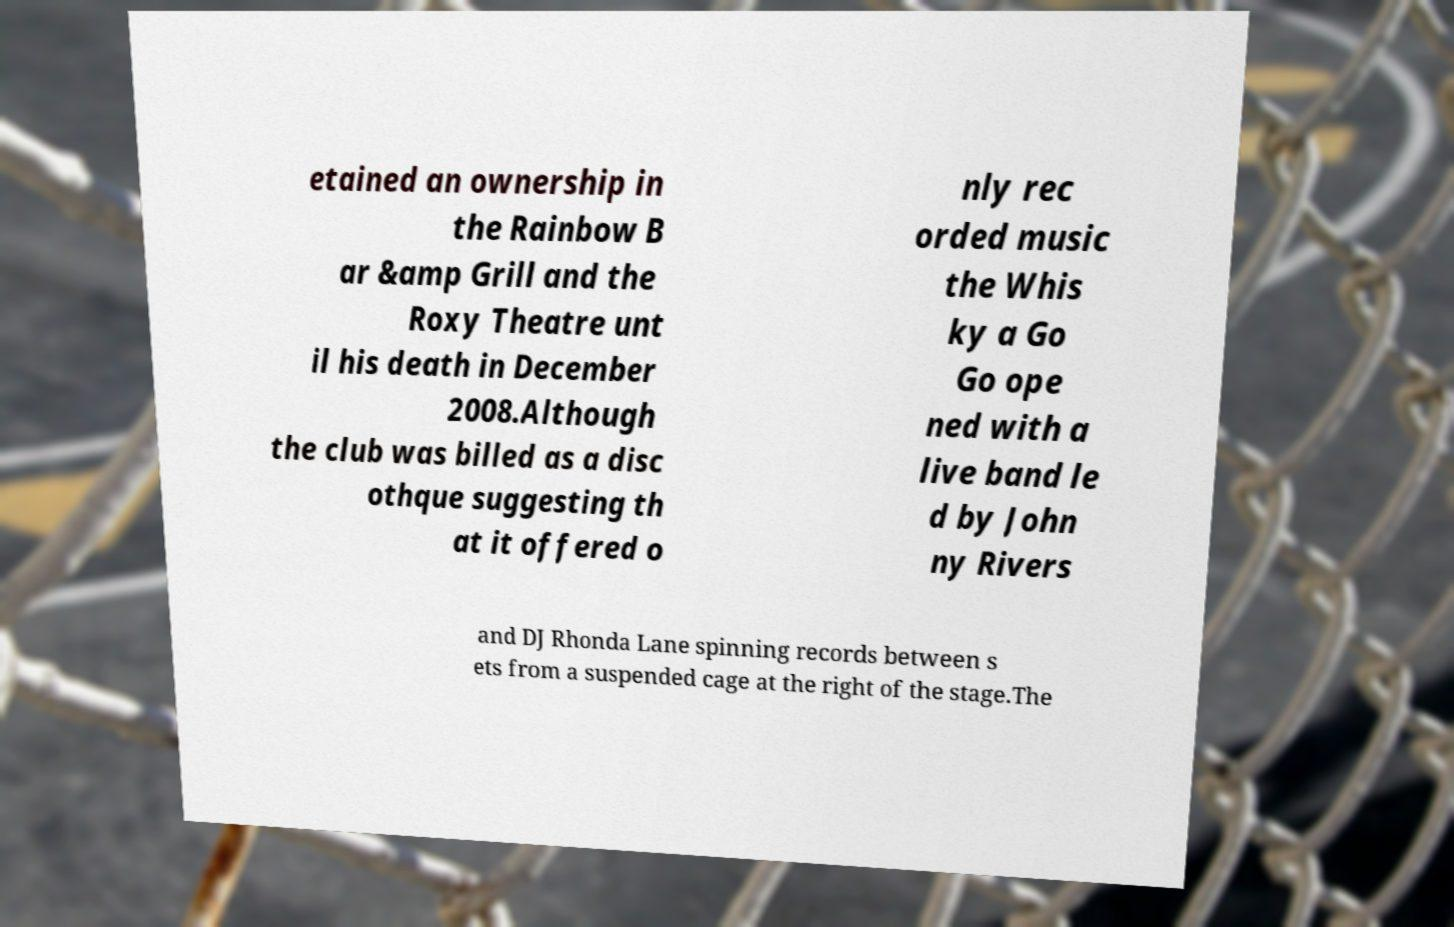Please identify and transcribe the text found in this image. etained an ownership in the Rainbow B ar &amp Grill and the Roxy Theatre unt il his death in December 2008.Although the club was billed as a disc othque suggesting th at it offered o nly rec orded music the Whis ky a Go Go ope ned with a live band le d by John ny Rivers and DJ Rhonda Lane spinning records between s ets from a suspended cage at the right of the stage.The 